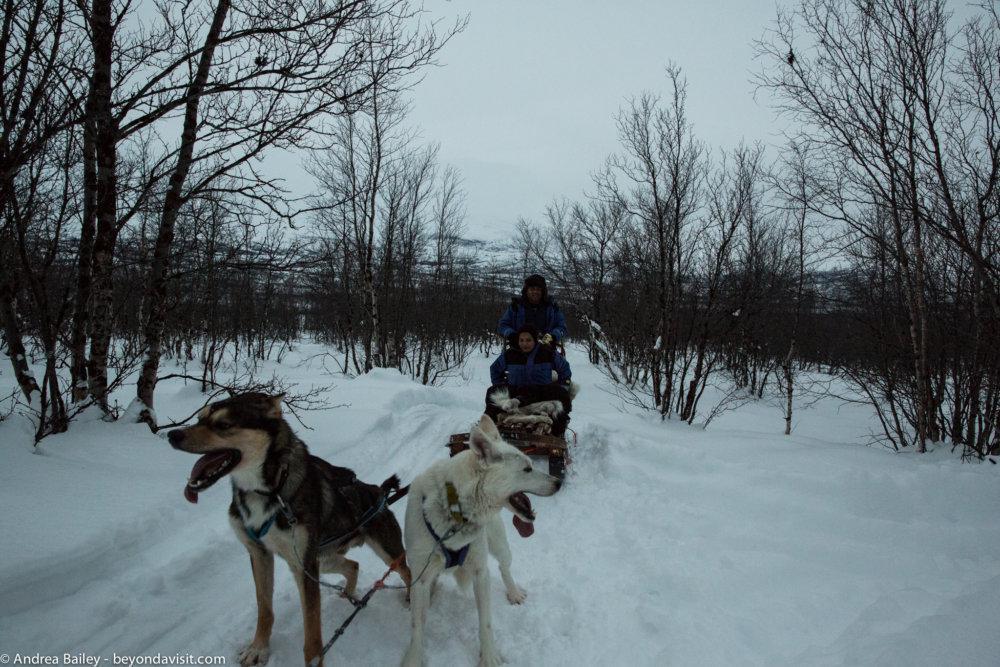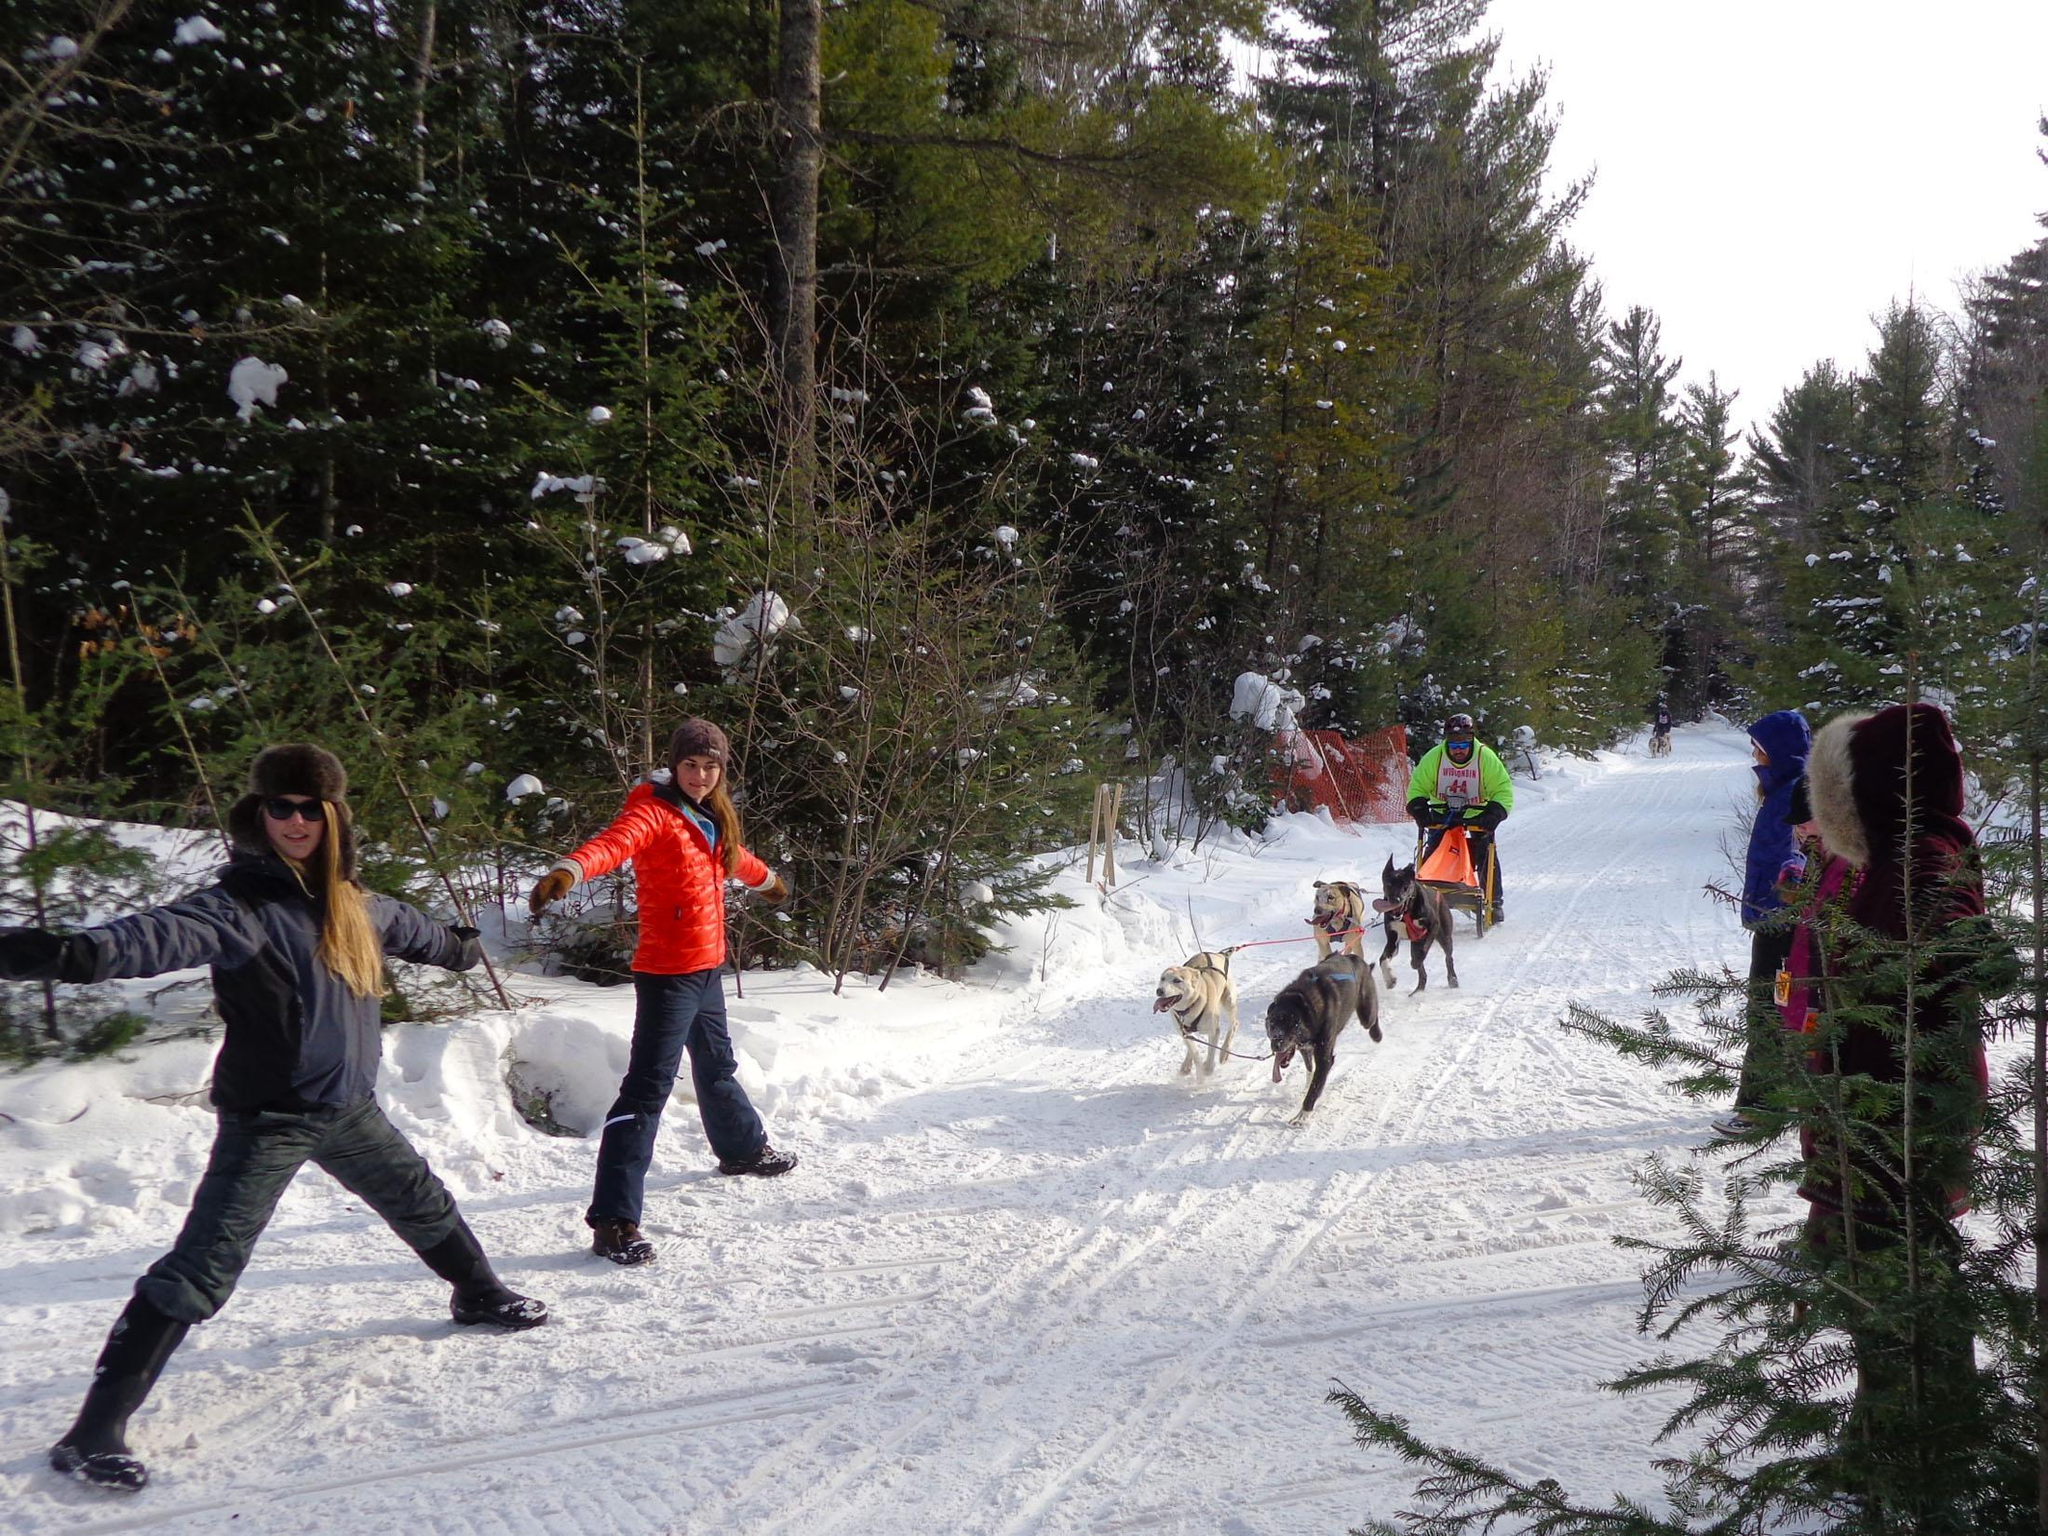The first image is the image on the left, the second image is the image on the right. Considering the images on both sides, is "Two people with outspread arms and spread legs are standing on the left as a sled dog team is coming down the trail." valid? Answer yes or no. Yes. The first image is the image on the left, the second image is the image on the right. Analyze the images presented: Is the assertion "There are four people with their arms and legs spread to help the sled dogs run on the path." valid? Answer yes or no. Yes. 